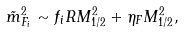Convert formula to latex. <formula><loc_0><loc_0><loc_500><loc_500>\tilde { m } _ { F _ { i } } ^ { 2 } \sim f _ { i } R M _ { 1 / 2 } ^ { 2 } + \eta _ { F } M _ { 1 / 2 } ^ { 2 } ,</formula> 